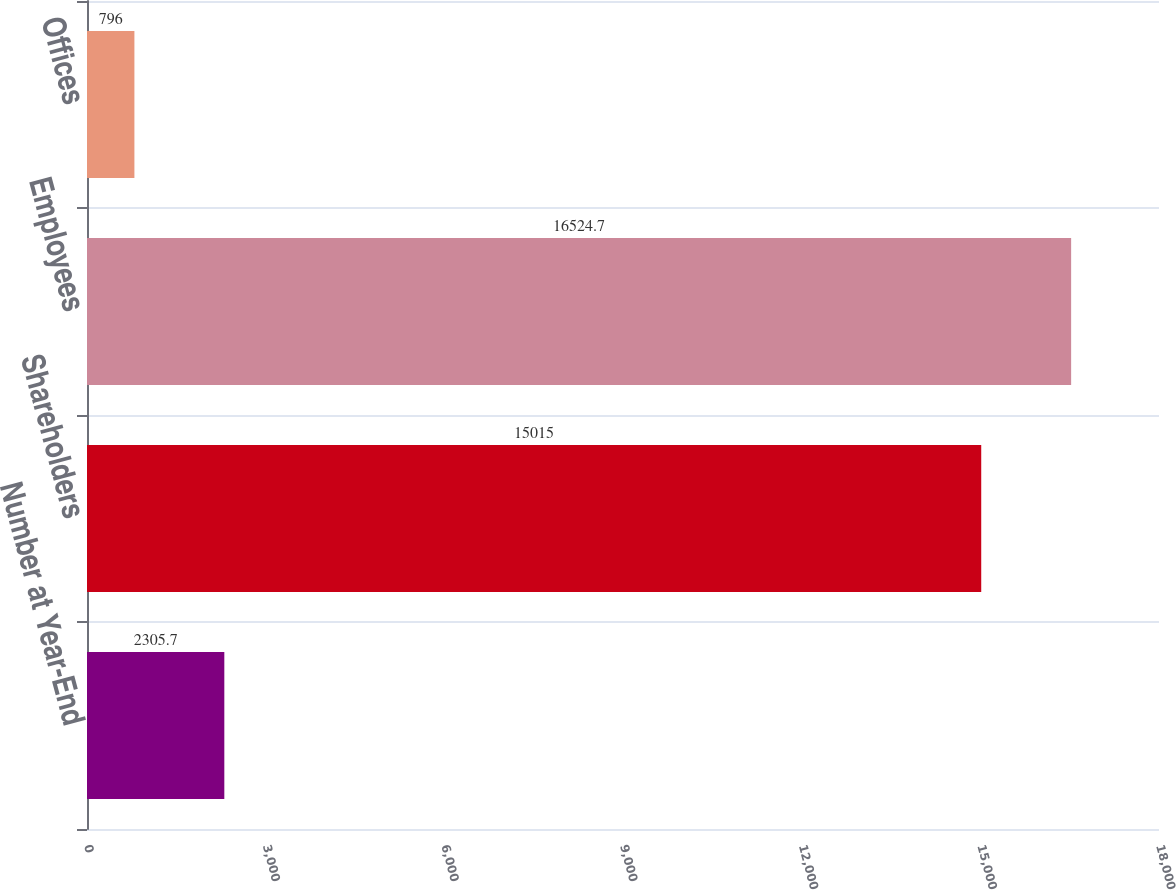Convert chart to OTSL. <chart><loc_0><loc_0><loc_500><loc_500><bar_chart><fcel>Number at Year-End<fcel>Shareholders<fcel>Employees<fcel>Offices<nl><fcel>2305.7<fcel>15015<fcel>16524.7<fcel>796<nl></chart> 